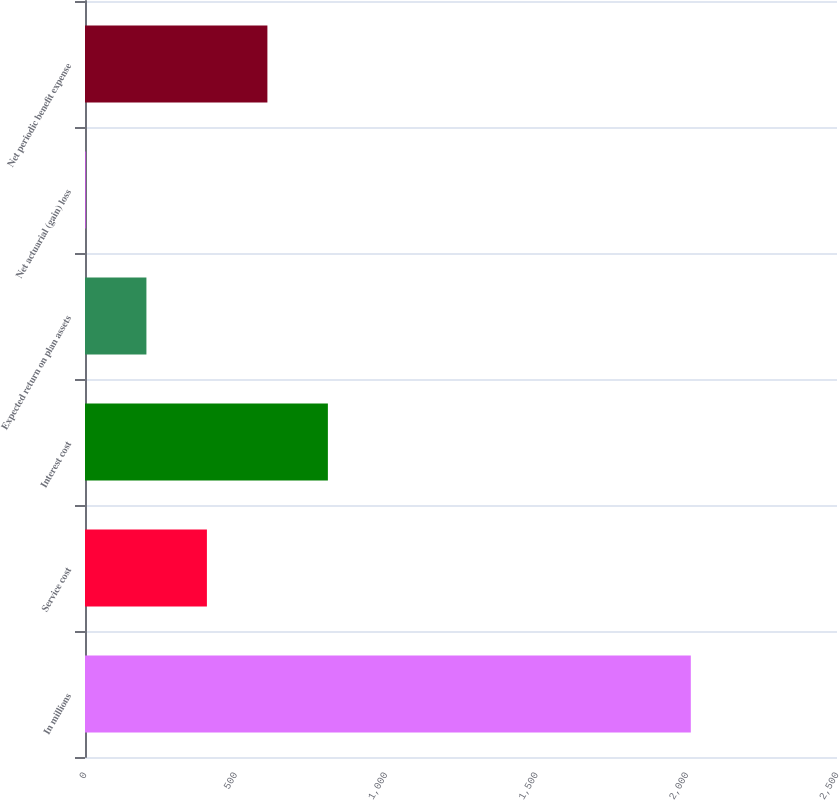Convert chart. <chart><loc_0><loc_0><loc_500><loc_500><bar_chart><fcel>In millions<fcel>Service cost<fcel>Interest cost<fcel>Expected return on plan assets<fcel>Net actuarial (gain) loss<fcel>Net periodic benefit expense<nl><fcel>2014<fcel>405.28<fcel>807.46<fcel>204.19<fcel>3.1<fcel>606.37<nl></chart> 